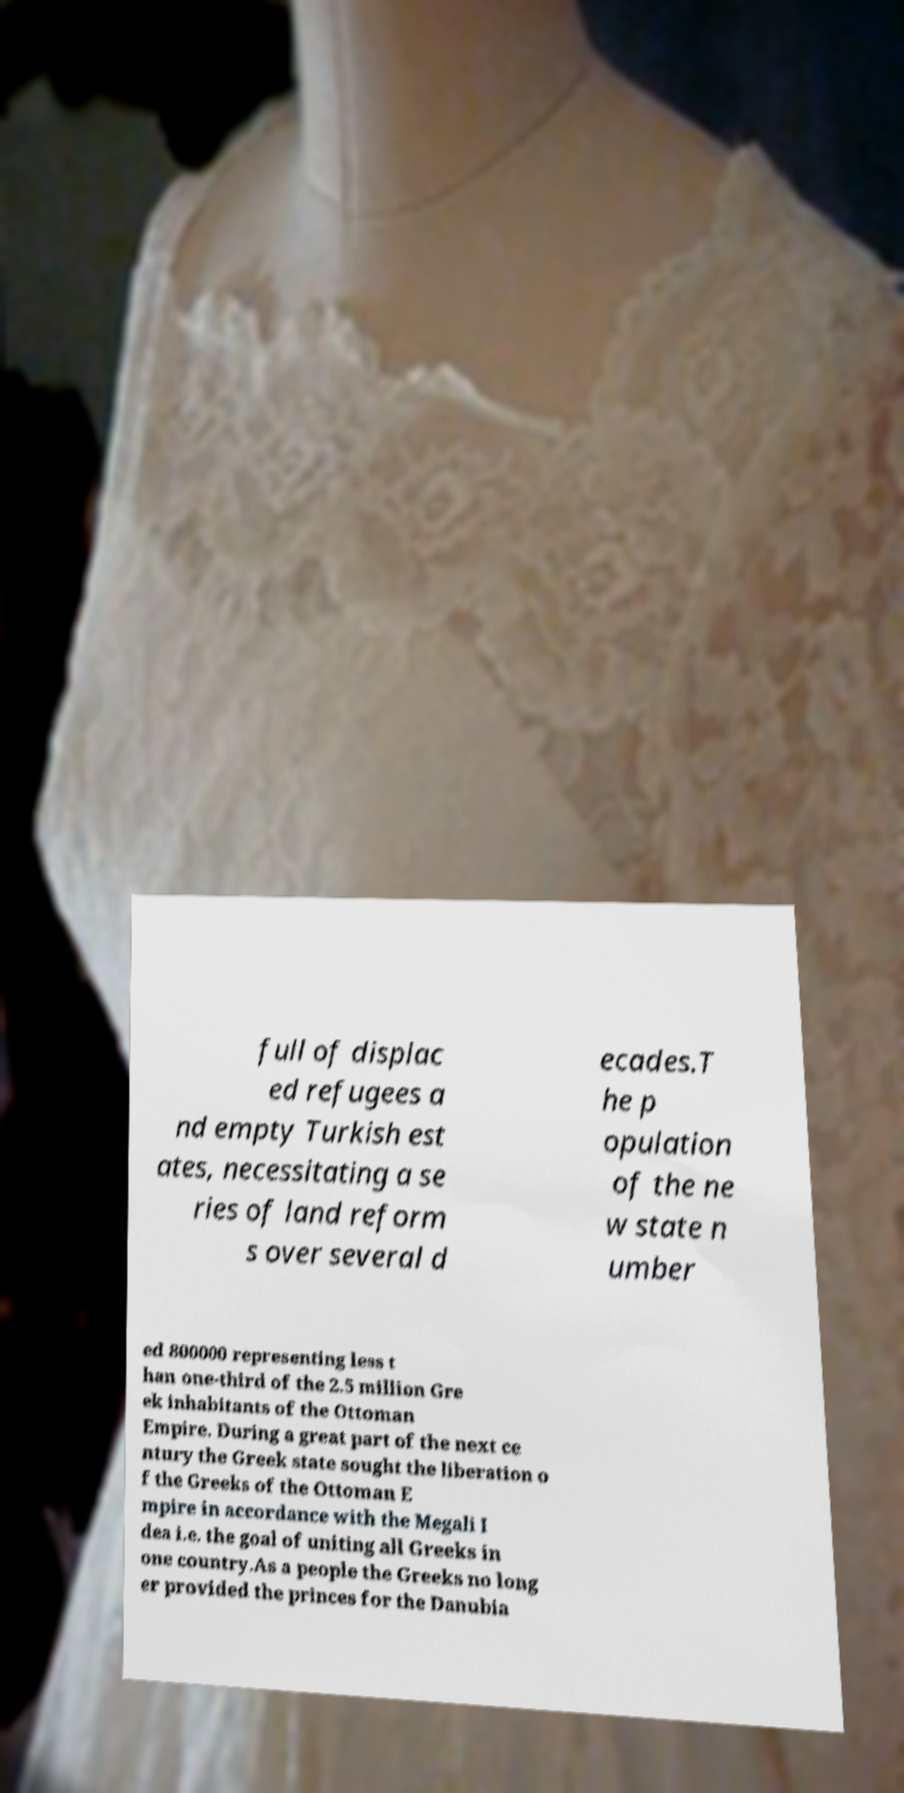What messages or text are displayed in this image? I need them in a readable, typed format. full of displac ed refugees a nd empty Turkish est ates, necessitating a se ries of land reform s over several d ecades.T he p opulation of the ne w state n umber ed 800000 representing less t han one-third of the 2.5 million Gre ek inhabitants of the Ottoman Empire. During a great part of the next ce ntury the Greek state sought the liberation o f the Greeks of the Ottoman E mpire in accordance with the Megali I dea i.e. the goal of uniting all Greeks in one country.As a people the Greeks no long er provided the princes for the Danubia 